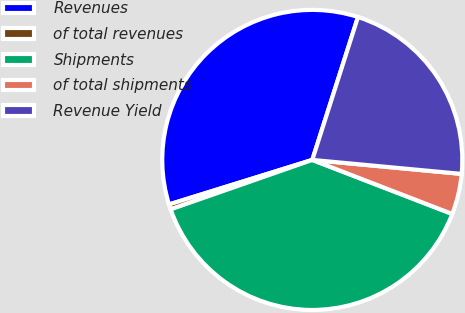<chart> <loc_0><loc_0><loc_500><loc_500><pie_chart><fcel>Revenues<fcel>of total revenues<fcel>Shipments<fcel>of total shipments<fcel>Revenue Yield<nl><fcel>34.72%<fcel>0.55%<fcel>38.79%<fcel>4.38%<fcel>21.56%<nl></chart> 